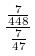<formula> <loc_0><loc_0><loc_500><loc_500>\frac { \frac { 7 } { 4 4 8 } } { \frac { 7 } { 4 7 } }</formula> 